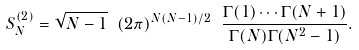<formula> <loc_0><loc_0><loc_500><loc_500>S ^ { ( 2 ) } _ { N } = \sqrt { N - 1 } \ ( 2 \pi ) ^ { N ( N - 1 ) / 2 } \ \frac { \Gamma ( 1 ) \cdots \Gamma ( N + 1 ) } { \Gamma ( N ) \Gamma ( N ^ { 2 } - 1 ) } .</formula> 